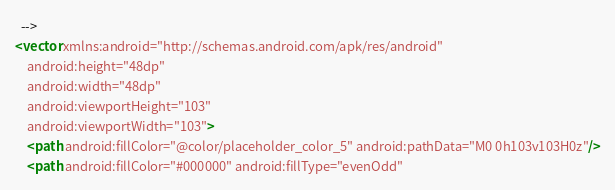Convert code to text. <code><loc_0><loc_0><loc_500><loc_500><_XML_>  -->
<vector xmlns:android="http://schemas.android.com/apk/res/android"
    android:height="48dp"
    android:width="48dp"
    android:viewportHeight="103"
    android:viewportWidth="103">
    <path android:fillColor="@color/placeholder_color_5" android:pathData="M0 0h103v103H0z"/>
    <path android:fillColor="#000000" android:fillType="evenOdd"</code> 